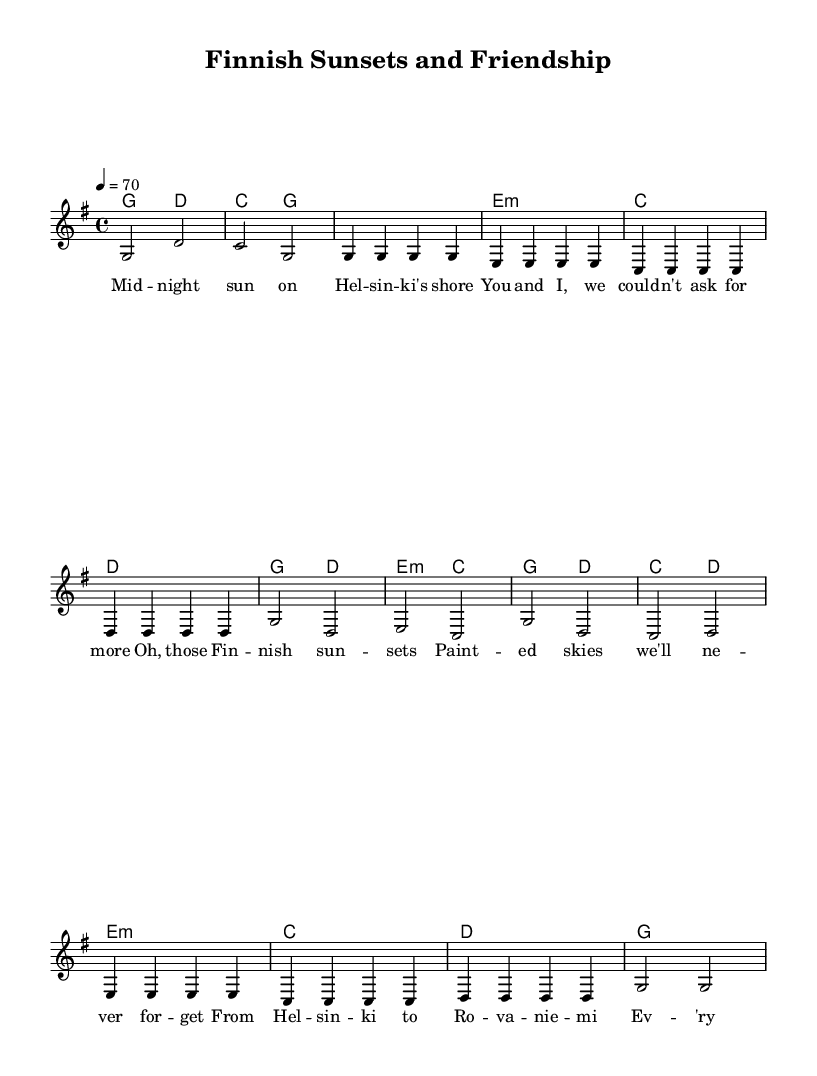What is the key signature of this music? The key signature is G major, which has one sharp (F#). This can be determined by looking at the key signature indicated at the beginning of the score.
Answer: G major What is the time signature of this music? The time signature is 4/4, which can be seen in the left side of the staff at the beginning of the score. This means there are four beats in each measure, and a quarter note gets one beat.
Answer: 4/4 What is the tempo marking of this music? The tempo marking is 70 beats per minute, indicated at the beginning of the score as "4 = 70". This tells the musician how fast to play the piece.
Answer: 70 How many measures are in the verse section? The verse section contains 8 measures. This can be counted by looking at the number of bar lines in the verse lyrics, which denote the end of each measure.
Answer: 8 Which chord is played in the chorus along with the note C? The chord played along with the note C in the chorus is E minor. This can be determined by examining the harmonies written above the melody in the chorus section.
Answer: E minor What melodic motif is repeated in the verse? The melodic motif that is repeated in the verse is the G note. This is observed by looking at the notes written for the melody where G appears multiple times consistently throughout the verse.
Answer: G How does the bridge section differ from the verse regarding note length? The bridge section has mostly quarter notes, while the verse has mostly eighth notes. This can be determined by examining the note types and their durations illustrated in each section of the score.
Answer: Quarter notes 